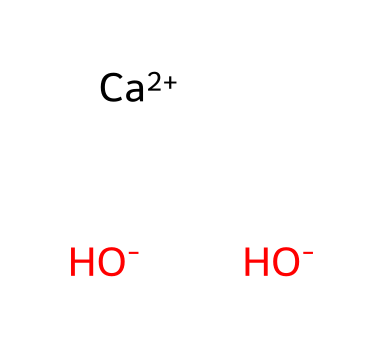What is the molecular formula of the compound shown? The compound consists of one calcium ion (Ca) followed by two hydroxide ions (OH). Thus, the total molecular formula is Ca(OH)2.
Answer: Ca(OH)2 How many hydroxide ions are present in this compound? The chemical representation shows two hydroxide ions (OH-), which can be counted directly from the arrangement.
Answer: 2 What is the charge of the calcium ion in this compound? The calcium ion in the structure is denoted as [Ca+2], indicating that it has a charge of +2.
Answer: +2 Is this compound an acid, base, or salt? Calcium hydroxide is classified as a base due to the presence of hydroxide ions (OH-) that can accept protons.
Answer: base How many total atoms are in the chemical structure? There is 1 calcium atom and 2 oxygen atoms from the hydroxide, along with 2 hydrogen atoms from the hydroxide, totaling 5 atoms in the compound.
Answer: 5 What role does this compound play in rust converters? Calcium hydroxide serves as a neutralizing agent that reacts with acids and helps convert rust (iron oxide) to a more stable form.
Answer: neutralizing agent What type of reaction does calcium hydroxide facilitate in rust remediation? Calcium hydroxide facilitates a chemical reaction that converts insoluble iron oxides into a more stable, soluble form, essentially promoting the removal or passivation of rust.
Answer: conversion 